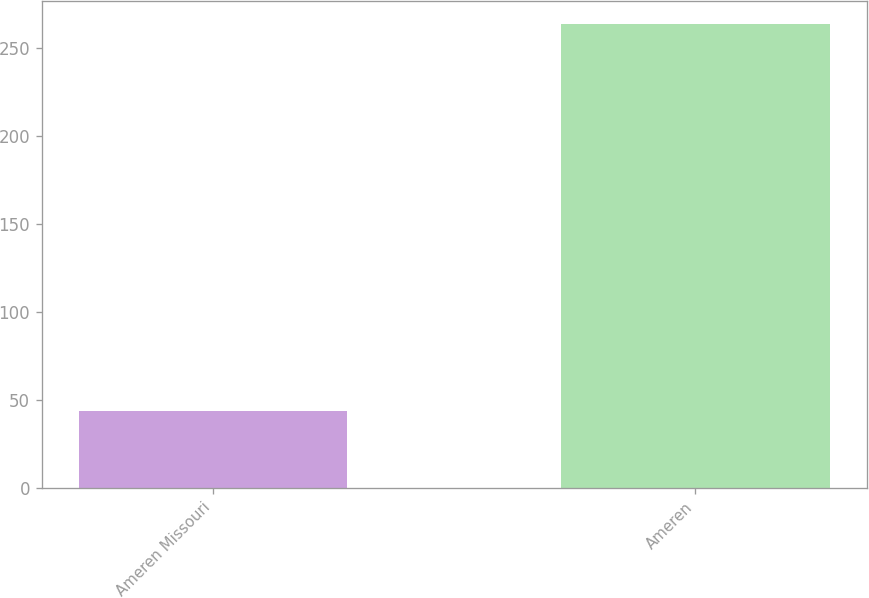<chart> <loc_0><loc_0><loc_500><loc_500><bar_chart><fcel>Ameren Missouri<fcel>Ameren<nl><fcel>44<fcel>264<nl></chart> 